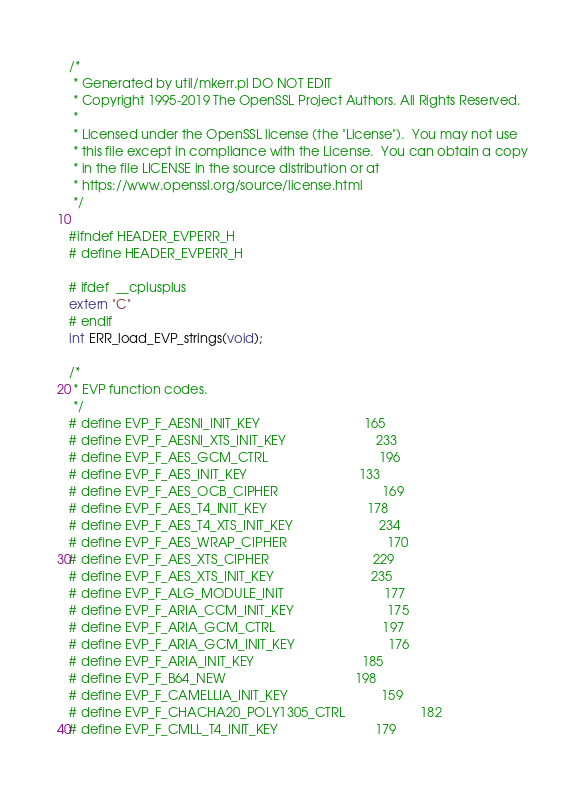<code> <loc_0><loc_0><loc_500><loc_500><_C_>/*
 * Generated by util/mkerr.pl DO NOT EDIT
 * Copyright 1995-2019 The OpenSSL Project Authors. All Rights Reserved.
 *
 * Licensed under the OpenSSL license (the "License").  You may not use
 * this file except in compliance with the License.  You can obtain a copy
 * in the file LICENSE in the source distribution or at
 * https://www.openssl.org/source/license.html
 */

#ifndef HEADER_EVPERR_H
# define HEADER_EVPERR_H

# ifdef  __cplusplus
extern "C"
# endif
int ERR_load_EVP_strings(void);

/*
 * EVP function codes.
 */
# define EVP_F_AESNI_INIT_KEY                             165
# define EVP_F_AESNI_XTS_INIT_KEY                         233
# define EVP_F_AES_GCM_CTRL                               196
# define EVP_F_AES_INIT_KEY                               133
# define EVP_F_AES_OCB_CIPHER                             169
# define EVP_F_AES_T4_INIT_KEY                            178
# define EVP_F_AES_T4_XTS_INIT_KEY                        234
# define EVP_F_AES_WRAP_CIPHER                            170
# define EVP_F_AES_XTS_CIPHER                             229
# define EVP_F_AES_XTS_INIT_KEY                           235
# define EVP_F_ALG_MODULE_INIT                            177
# define EVP_F_ARIA_CCM_INIT_KEY                          175
# define EVP_F_ARIA_GCM_CTRL                              197
# define EVP_F_ARIA_GCM_INIT_KEY                          176
# define EVP_F_ARIA_INIT_KEY                              185
# define EVP_F_B64_NEW                                    198
# define EVP_F_CAMELLIA_INIT_KEY                          159
# define EVP_F_CHACHA20_POLY1305_CTRL                     182
# define EVP_F_CMLL_T4_INIT_KEY                           179</code> 